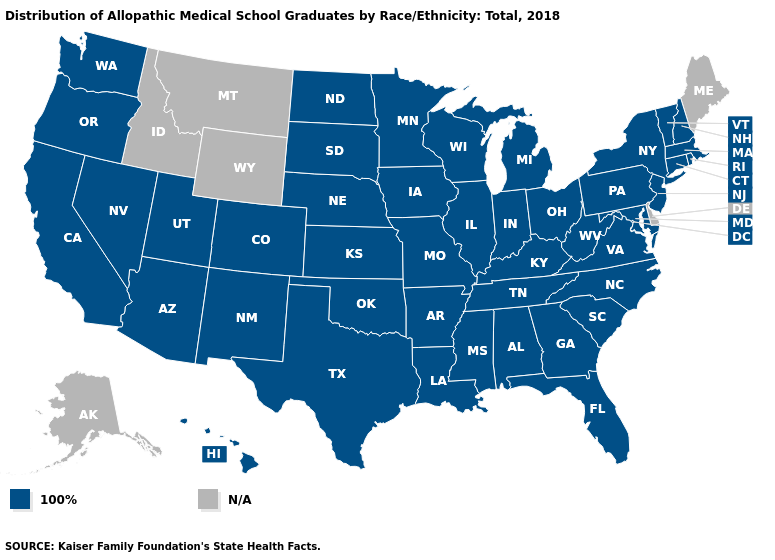What is the value of South Dakota?
Be succinct. 100%. Which states hav the highest value in the MidWest?
Write a very short answer. Illinois, Indiana, Iowa, Kansas, Michigan, Minnesota, Missouri, Nebraska, North Dakota, Ohio, South Dakota, Wisconsin. Among the states that border Virginia , which have the highest value?
Short answer required. Kentucky, Maryland, North Carolina, Tennessee, West Virginia. Name the states that have a value in the range 100%?
Answer briefly. Alabama, Arizona, Arkansas, California, Colorado, Connecticut, Florida, Georgia, Hawaii, Illinois, Indiana, Iowa, Kansas, Kentucky, Louisiana, Maryland, Massachusetts, Michigan, Minnesota, Mississippi, Missouri, Nebraska, Nevada, New Hampshire, New Jersey, New Mexico, New York, North Carolina, North Dakota, Ohio, Oklahoma, Oregon, Pennsylvania, Rhode Island, South Carolina, South Dakota, Tennessee, Texas, Utah, Vermont, Virginia, Washington, West Virginia, Wisconsin. What is the lowest value in the West?
Give a very brief answer. 100%. What is the highest value in states that border Illinois?
Write a very short answer. 100%. Name the states that have a value in the range N/A?
Keep it brief. Alaska, Delaware, Idaho, Maine, Montana, Wyoming. What is the value of California?
Give a very brief answer. 100%. What is the value of Wisconsin?
Keep it brief. 100%. What is the lowest value in states that border West Virginia?
Short answer required. 100%. What is the lowest value in the USA?
Write a very short answer. 100%. Which states have the lowest value in the MidWest?
Quick response, please. Illinois, Indiana, Iowa, Kansas, Michigan, Minnesota, Missouri, Nebraska, North Dakota, Ohio, South Dakota, Wisconsin. What is the highest value in the MidWest ?
Answer briefly. 100%. What is the value of Ohio?
Answer briefly. 100%. 